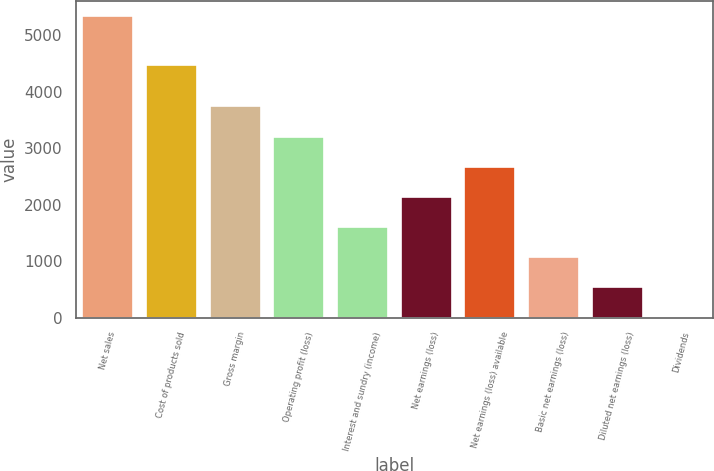Convert chart to OTSL. <chart><loc_0><loc_0><loc_500><loc_500><bar_chart><fcel>Net sales<fcel>Cost of products sold<fcel>Gross margin<fcel>Operating profit (loss)<fcel>Interest and sundry (income)<fcel>Net earnings (loss)<fcel>Net earnings (loss) available<fcel>Basic net earnings (loss)<fcel>Diluted net earnings (loss)<fcel>Dividends<nl><fcel>5347<fcel>4471<fcel>3743.23<fcel>3208.64<fcel>1604.87<fcel>2139.46<fcel>2674.05<fcel>1070.28<fcel>535.69<fcel>1.1<nl></chart> 